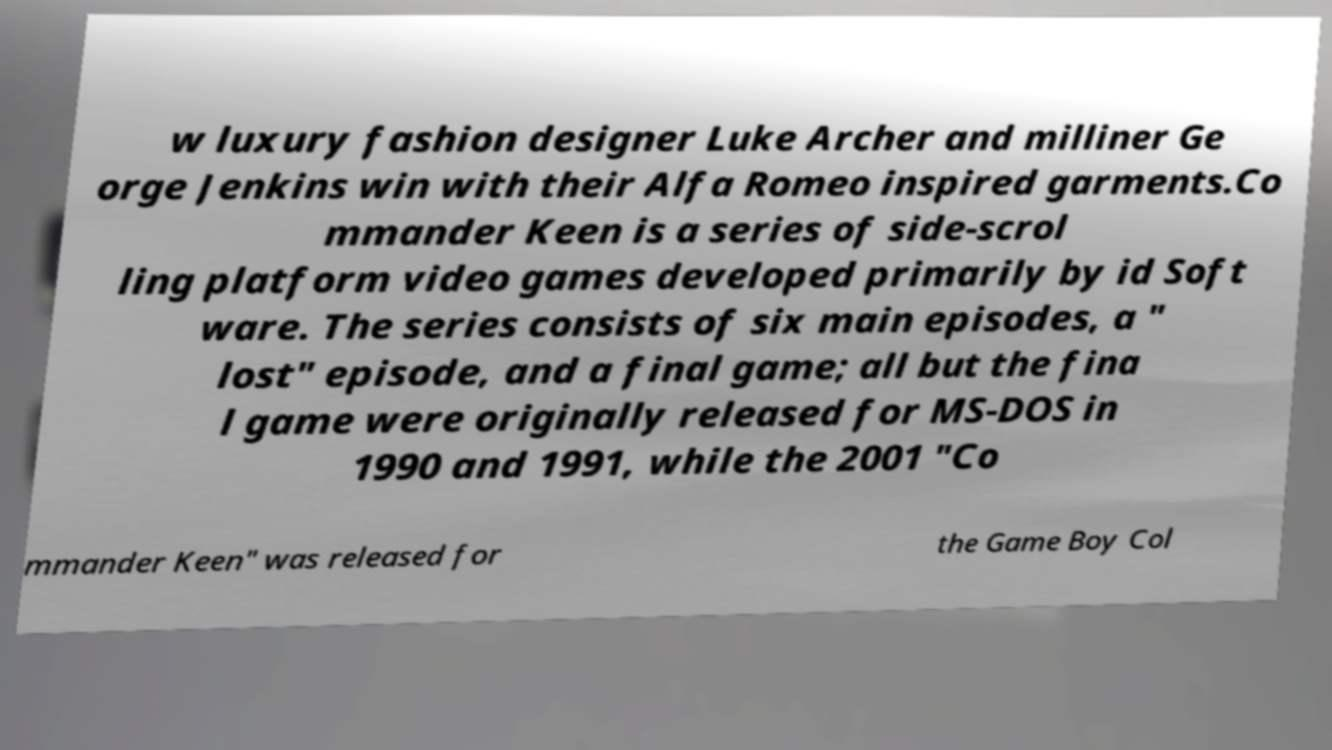What messages or text are displayed in this image? I need them in a readable, typed format. w luxury fashion designer Luke Archer and milliner Ge orge Jenkins win with their Alfa Romeo inspired garments.Co mmander Keen is a series of side-scrol ling platform video games developed primarily by id Soft ware. The series consists of six main episodes, a " lost" episode, and a final game; all but the fina l game were originally released for MS-DOS in 1990 and 1991, while the 2001 "Co mmander Keen" was released for the Game Boy Col 